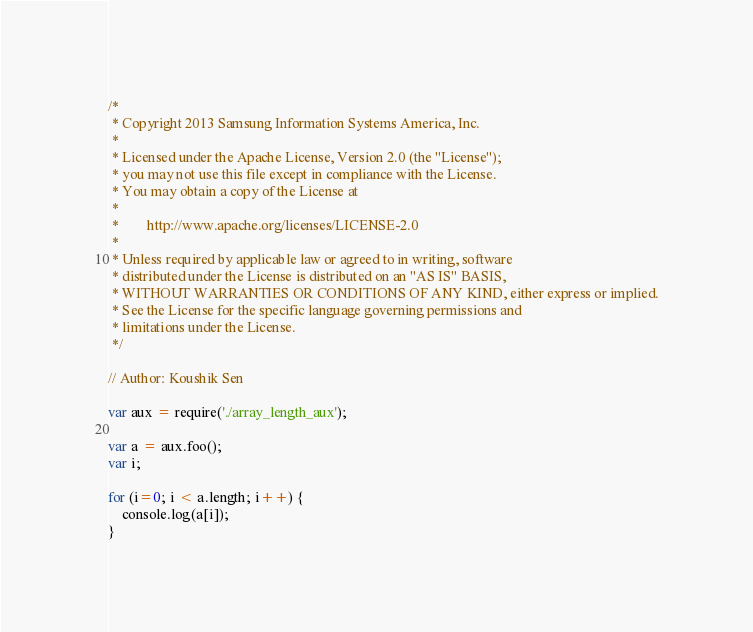<code> <loc_0><loc_0><loc_500><loc_500><_JavaScript_>/*
 * Copyright 2013 Samsung Information Systems America, Inc.
 * 
 * Licensed under the Apache License, Version 2.0 (the "License");
 * you may not use this file except in compliance with the License.
 * You may obtain a copy of the License at
 * 
 *        http://www.apache.org/licenses/LICENSE-2.0
 * 
 * Unless required by applicable law or agreed to in writing, software
 * distributed under the License is distributed on an "AS IS" BASIS,
 * WITHOUT WARRANTIES OR CONDITIONS OF ANY KIND, either express or implied.
 * See the License for the specific language governing permissions and
 * limitations under the License.
 */

// Author: Koushik Sen

var aux = require('./array_length_aux');

var a = aux.foo();
var i;

for (i=0; i < a.length; i++) {
    console.log(a[i]);
}
</code> 